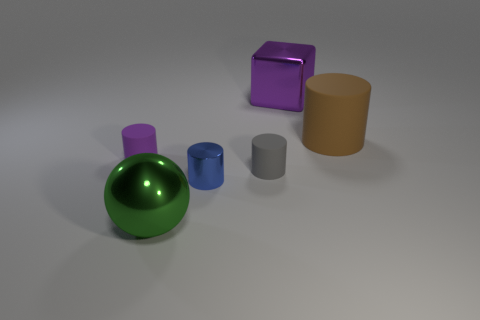There is a small thing that is the same color as the large metallic block; what is it made of?
Make the answer very short. Rubber. There is a tiny cylinder left of the big green shiny object; how many things are on the right side of it?
Keep it short and to the point. 5. What is the cylinder that is both behind the tiny gray thing and to the left of the big block made of?
Offer a very short reply. Rubber. There is a purple object that is the same size as the blue shiny cylinder; what shape is it?
Offer a terse response. Cylinder. What is the color of the thing that is behind the cylinder that is right of the purple thing on the right side of the blue metal cylinder?
Keep it short and to the point. Purple. What number of things are either rubber objects to the right of the gray object or big gray matte spheres?
Provide a succinct answer. 1. There is a cube that is the same size as the brown object; what material is it?
Your answer should be very brief. Metal. The purple object that is right of the cylinder that is left of the metallic object that is in front of the small metallic object is made of what material?
Provide a short and direct response. Metal. What is the color of the small metallic cylinder?
Ensure brevity in your answer.  Blue. What number of tiny things are either blue shiny things or gray cylinders?
Provide a short and direct response. 2. 